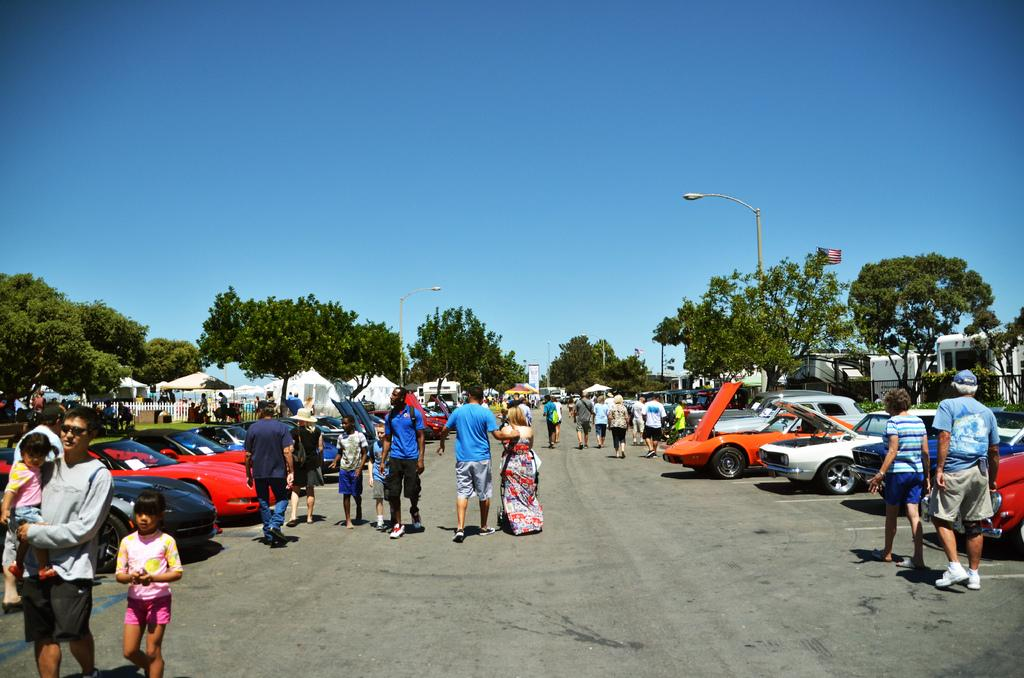What types of objects can be seen in the image? There are vehicles, a group of people, a fence, lights, poles, tents, and trees visible in the image. Can you describe the setting of the image? The image features a group of people standing near vehicles, tents, and trees, with a fence and lights in the background. What is visible in the sky in the image? The sky is visible in the background of the image. What type of salt can be seen on the letters in the image? There are no letters or salt present in the image. How does the bit of information affect the people standing in the image? There is no specific bit of information mentioned in the image, so it cannot be determined how it would affect the people standing there. 